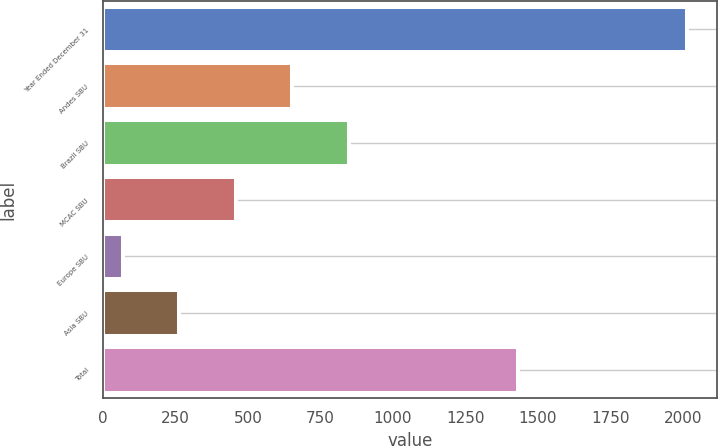Convert chart to OTSL. <chart><loc_0><loc_0><loc_500><loc_500><bar_chart><fcel>Year Ended December 31<fcel>Andes SBU<fcel>Brazil SBU<fcel>MCAC SBU<fcel>Europe SBU<fcel>Asia SBU<fcel>Total<nl><fcel>2016<fcel>652.4<fcel>847.2<fcel>457.6<fcel>68<fcel>262.8<fcel>1431<nl></chart> 